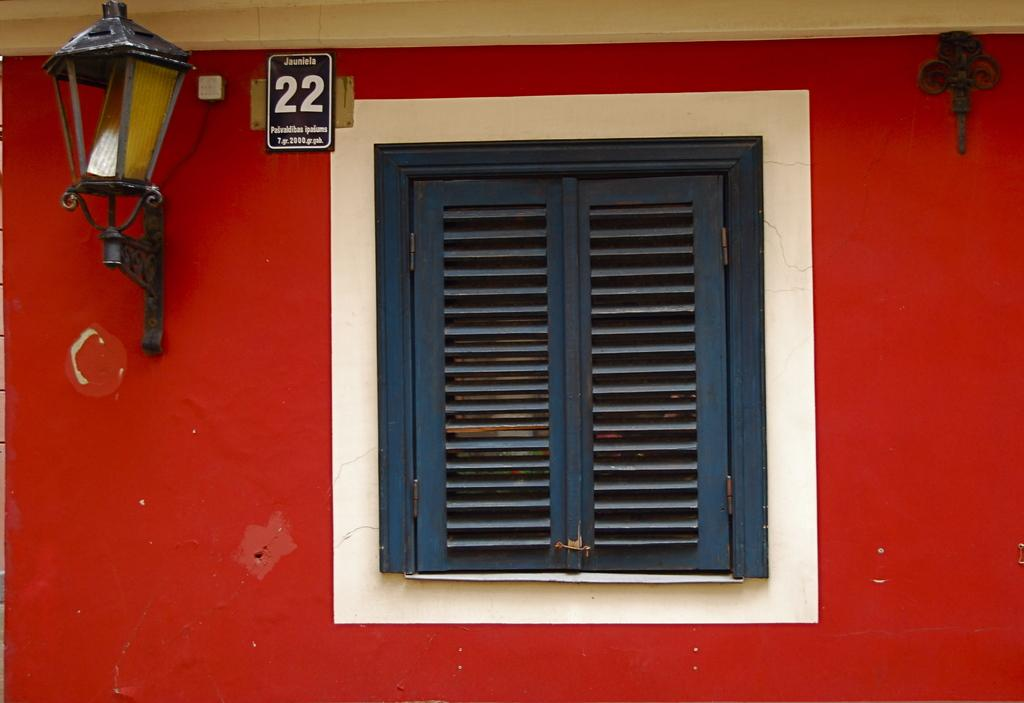What can be seen in the image that provides a view of the outside? There is a window in the image that provides a view of the outside. What type of lighting is present in the image? There is a light lamp on the wall in the image. What is the board with text and numbers used for in the image? The board with text and numbers is likely used for displaying information or instructions. What type of hose is connected to the light lamp in the image? There is no hose connected to the light lamp in the image. How many fingers are visible on the board with text and numbers in the image? There are no fingers visible on the board with text and numbers in the image. 